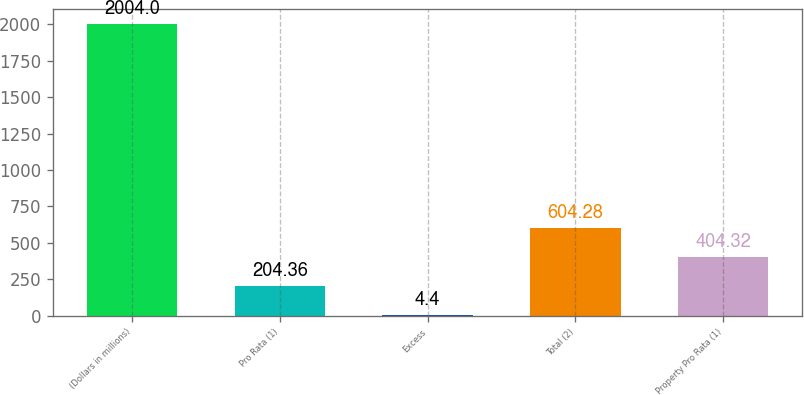Convert chart to OTSL. <chart><loc_0><loc_0><loc_500><loc_500><bar_chart><fcel>(Dollars in millions)<fcel>Pro Rata (1)<fcel>Excess<fcel>Total (2)<fcel>Property Pro Rata (1)<nl><fcel>2004<fcel>204.36<fcel>4.4<fcel>604.28<fcel>404.32<nl></chart> 